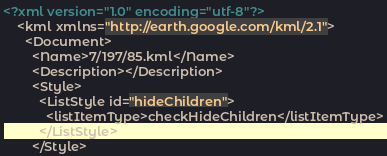<code> <loc_0><loc_0><loc_500><loc_500><_XML_><?xml version="1.0" encoding="utf-8"?>
	<kml xmlns="http://earth.google.com/kml/2.1">
	  <Document>
	    <Name>7/197/85.kml</Name>
	    <Description></Description>
	    <Style>
	      <ListStyle id="hideChildren">
	        <listItemType>checkHideChildren</listItemType>
	      </ListStyle>
	    </Style></code> 